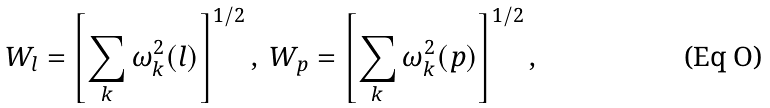<formula> <loc_0><loc_0><loc_500><loc_500>W _ { l } = \left [ \sum _ { k } \omega ^ { 2 } _ { k } ( l ) \right ] ^ { 1 / 2 } , \ W _ { p } = \left [ \sum _ { k } \omega ^ { 2 } _ { k } ( p ) \right ] ^ { 1 / 2 } ,</formula> 